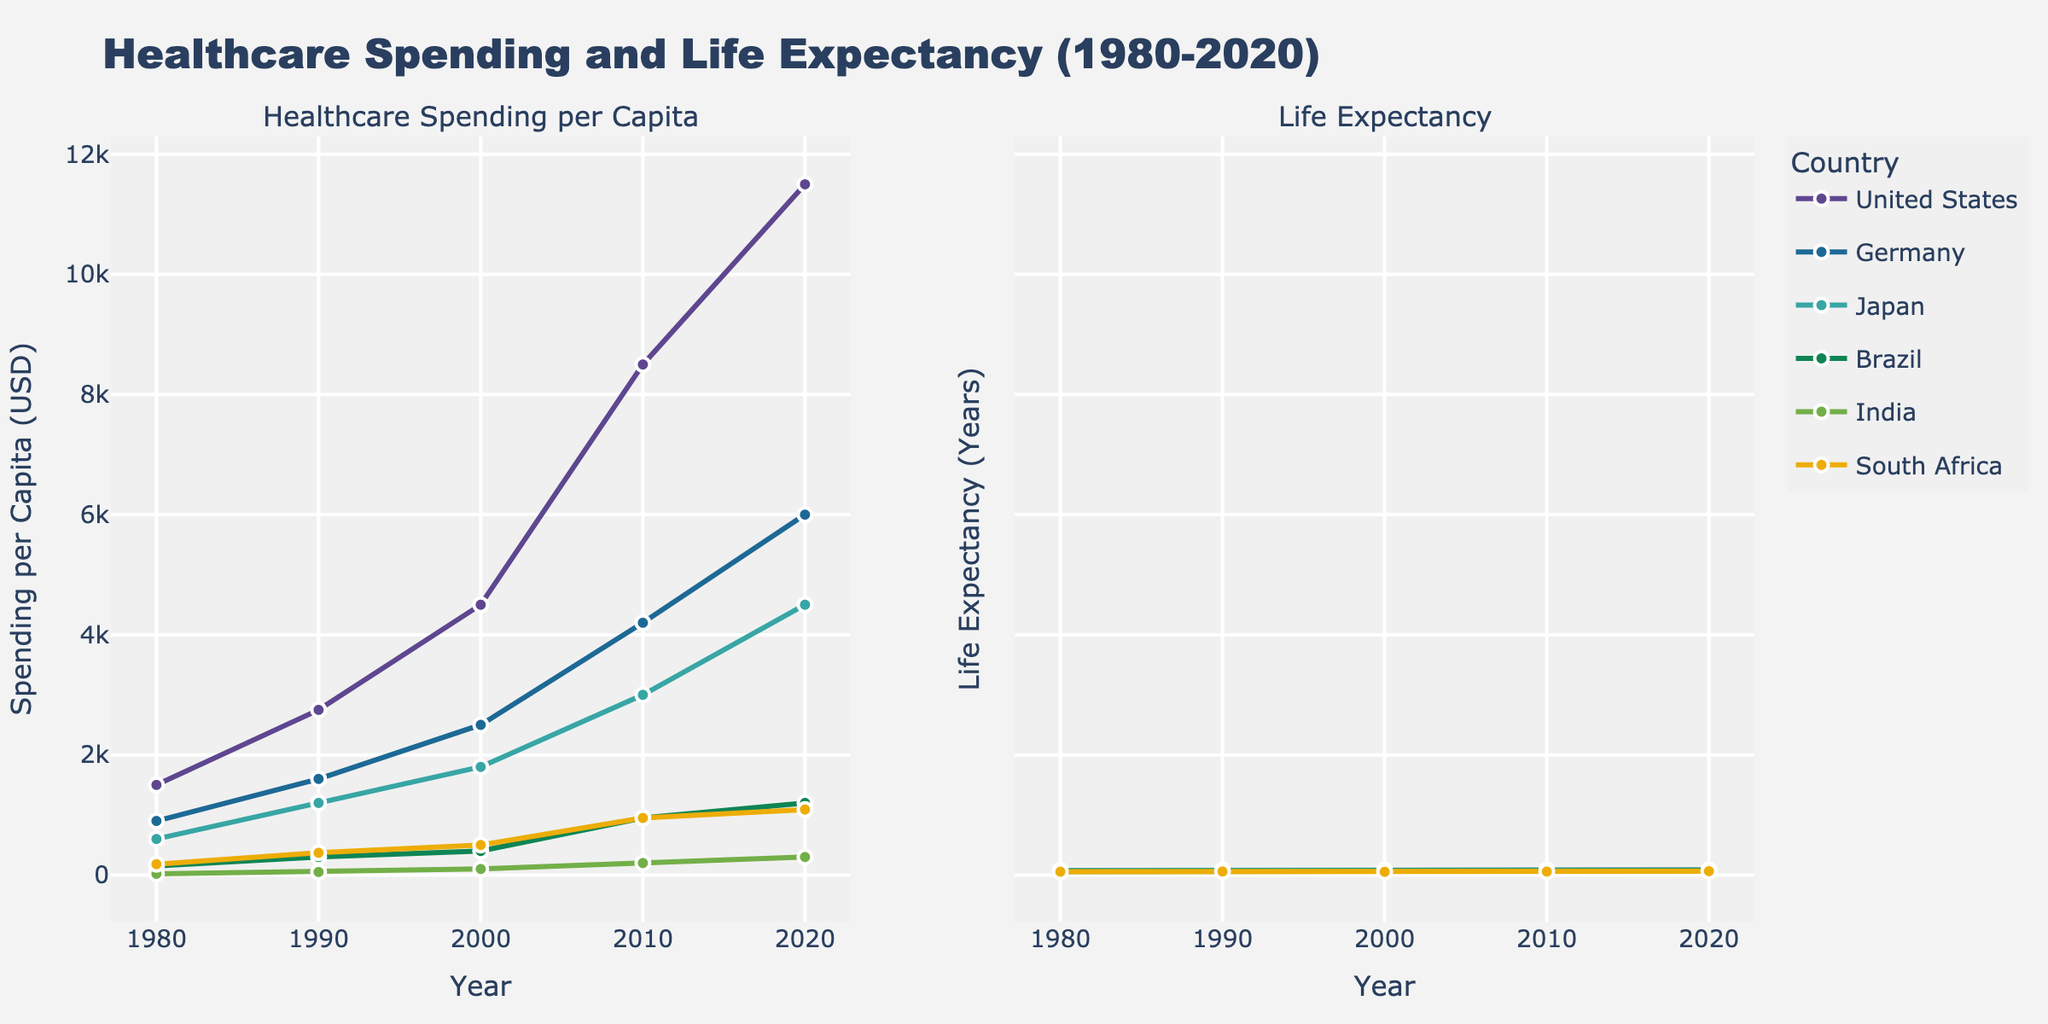What is the title of the figure? The title of the figure can be found at the top, centering both subplots. It reads "Healthcare Spending and Life Expectancy (1980-2020)"
Answer: Healthcare Spending and Life Expectancy (1980-2020) What does the x-axis represent in both subplots? The x-axis covers the same representation in both subplots, which is the 'Year'. This is visibly marked along the horizontal axes on both subplots.
Answer: Year How many countries are visualized in the plot? The number of unique countries can be determined by examining the legend on the left subplot. Each country is represented by a different color and name.
Answer: 6 Which country had the highest healthcare spending per capita in 2020? To find this, locate the data points for the year 2020 in the healthcare spending subplot (left). The country with the highest point at this year is the United States.
Answer: United States How does the life expectancy in Japan compare to the United States in 2020? Look at the corresponding data points for 2020 in the life expectancy subplot (right). Japan's data point is higher compared to the United States, indicating higher life expectancy.
Answer: Japan's life expectancy is higher What is the trend in life expectancy in Germany from 1980 to 2020? Follow the line representing Germany from the year 1980 to 2020 in the right subplot. The trend shows an increasing pattern throughout the 40 years.
Answer: Increasing trend Which country shows the most significant improvement in life expectancy from 1980 to 2020? Calculate the difference between the 1980 and 2020 data points in the life expectancy subplot for all countries. South Africa shows the most significant improvement (from 55.3 to 64.1).
Answer: South Africa What is the approximate increase in healthcare spending per capita for Brazil from 1980 to 2020? Identify Brazil's data points for 1980 and 2020 in the healthcare spending subplot. The increase is calculated from $150 to approximately $1200 per capita. So, $1200 - $150 = $1050.
Answer: $1050 Comparing healthcare spending per capita in 2010, which country spent the least and by how much? Locate the data points for 2010 in the healthcare spending subplot. The country with the lowest spending is India at $200. By checking the remaining countries, India spent significantly less compared to even the next lowest (Brazil at $950). The difference is $950 - $200 = $750.
Answer: India, by $750 